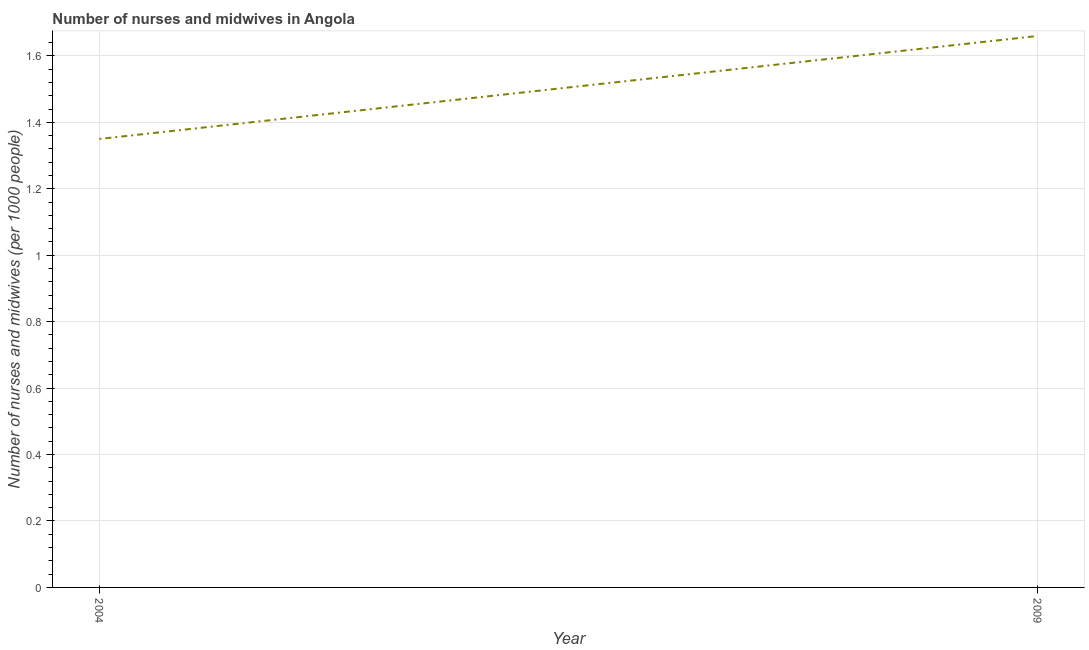What is the number of nurses and midwives in 2004?
Make the answer very short. 1.35. Across all years, what is the maximum number of nurses and midwives?
Your answer should be compact. 1.66. Across all years, what is the minimum number of nurses and midwives?
Ensure brevity in your answer.  1.35. In which year was the number of nurses and midwives maximum?
Offer a terse response. 2009. What is the sum of the number of nurses and midwives?
Provide a succinct answer. 3.01. What is the difference between the number of nurses and midwives in 2004 and 2009?
Your answer should be very brief. -0.31. What is the average number of nurses and midwives per year?
Your response must be concise. 1.5. What is the median number of nurses and midwives?
Give a very brief answer. 1.5. What is the ratio of the number of nurses and midwives in 2004 to that in 2009?
Make the answer very short. 0.81. Is the number of nurses and midwives in 2004 less than that in 2009?
Your answer should be very brief. Yes. Does the number of nurses and midwives monotonically increase over the years?
Ensure brevity in your answer.  Yes. How many lines are there?
Your answer should be compact. 1. How many years are there in the graph?
Provide a short and direct response. 2. Are the values on the major ticks of Y-axis written in scientific E-notation?
Offer a very short reply. No. What is the title of the graph?
Your answer should be very brief. Number of nurses and midwives in Angola. What is the label or title of the X-axis?
Provide a succinct answer. Year. What is the label or title of the Y-axis?
Provide a succinct answer. Number of nurses and midwives (per 1000 people). What is the Number of nurses and midwives (per 1000 people) in 2004?
Your answer should be compact. 1.35. What is the Number of nurses and midwives (per 1000 people) in 2009?
Provide a succinct answer. 1.66. What is the difference between the Number of nurses and midwives (per 1000 people) in 2004 and 2009?
Your answer should be very brief. -0.31. What is the ratio of the Number of nurses and midwives (per 1000 people) in 2004 to that in 2009?
Provide a short and direct response. 0.81. 